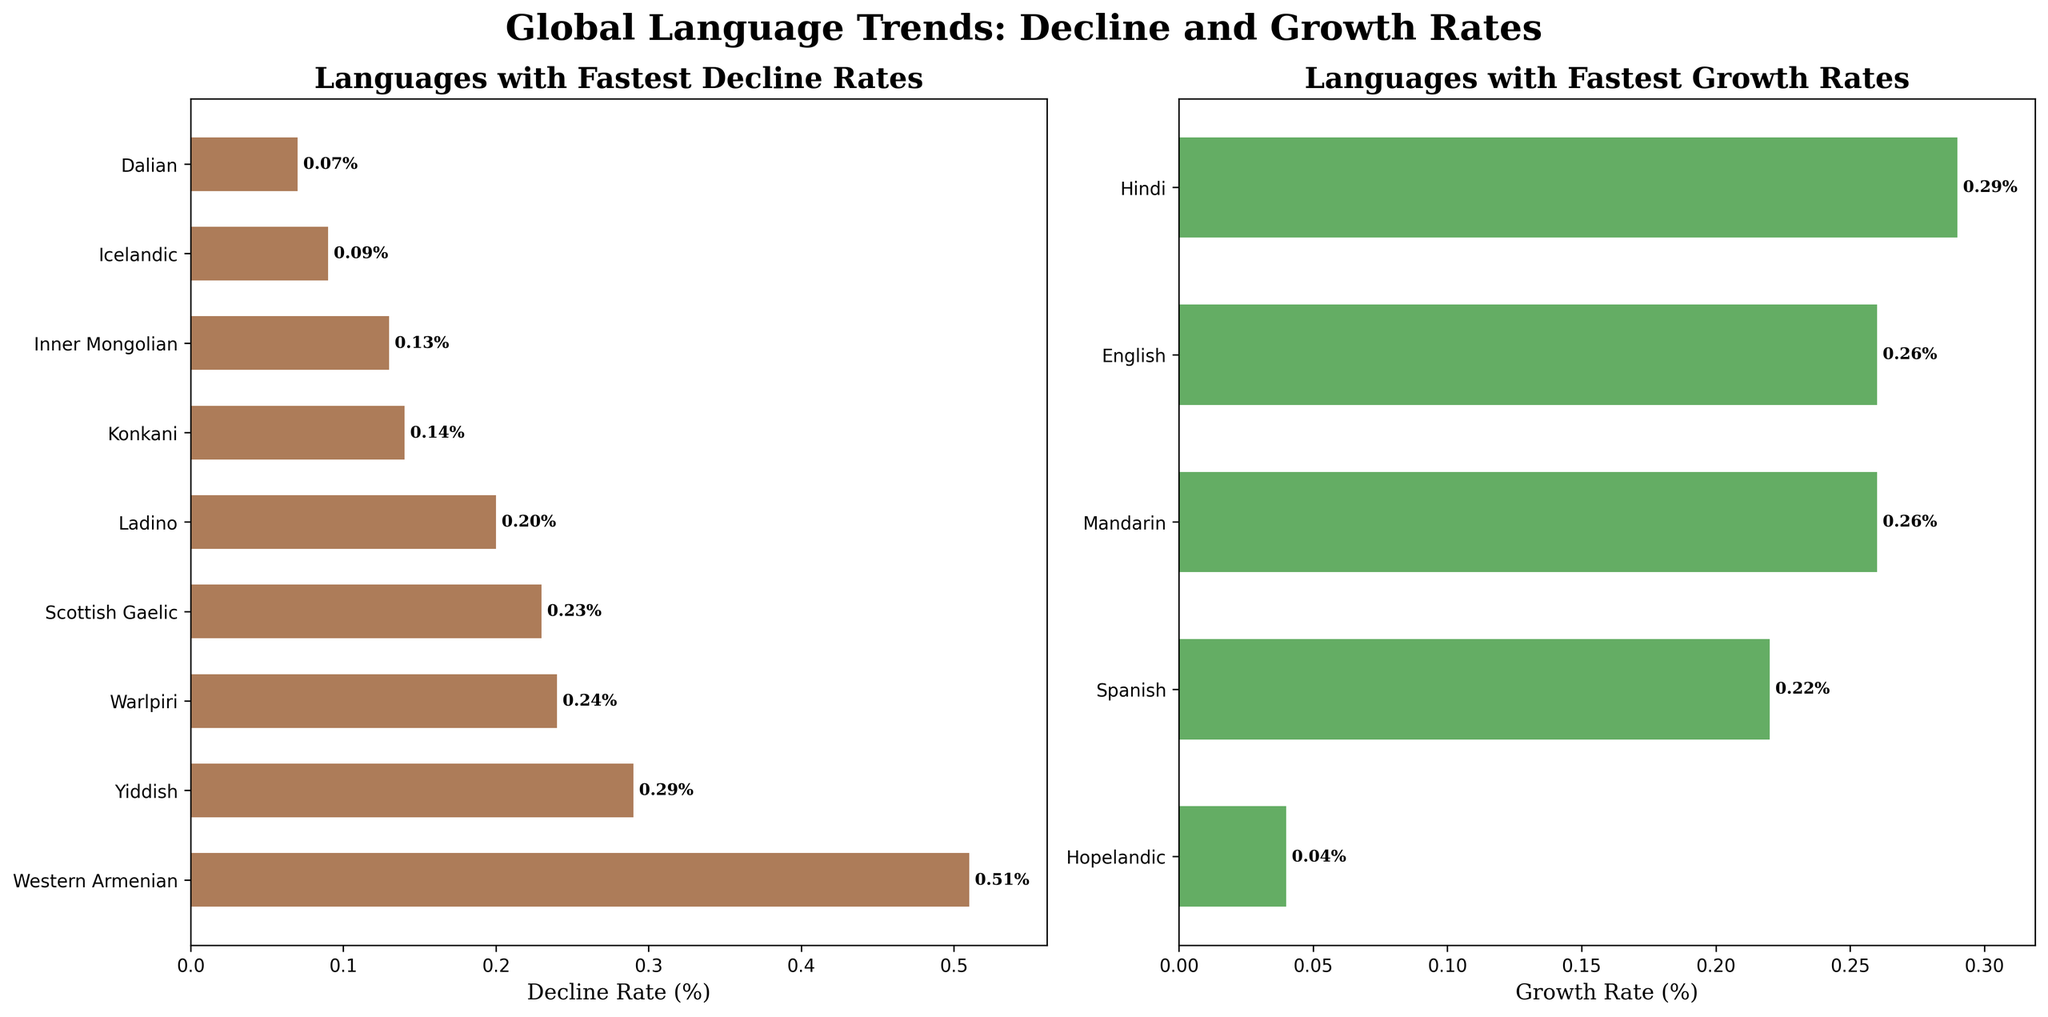What is the title of the figure? The title is displayed at the top of the figure in large, bold, and serif font, indicating the overall theme of the figure.
Answer: Global Language Trends: Decline and Growth Rates Which languages are shown to have the fastest decline rate? The left subplot titled "Languages with Fastest Decline Rates" shows languages with the fastest decline rates. From the top of the bar chart, we can see that Western Armenian has the highest decline rate.
Answer: Western Armenian How many languages are presented in the "Languages with Fastest Growth Rates" subplot? In the right subplot titled "Languages with Fastest Growth Rates," counting the bars will give the number of languages shown. There are five bars in this subplot.
Answer: 5 Between Mandarin and English, which language has a higher projected growth rate and what are the values? The right subplot lists Mandarin and English’s growth rates side-by-side. By comparing the two bars’ lengths, we see Mandarin has a growth rate of 0.26%, and English also at 0.26%.
Answer: They both have the same growth rate of 0.26% Which language has the lowest decline rate among the declining languages? In the left subplot titled "Languages with Fastest Decline Rates", the lowest bar represents the language with the smallest decline rate. The language at the bottom is Dalian.
Answer: Dalian How does the growth rate of Spanish compare to that of Hindi? Both growth rates can be found in the right subplot. Spanish’s bar shows a growth rate of 0.22%, whereas Hindi's bar shows a growth rate of 0.29%. Since Hindi’s bar is longer, Hindi has a higher growth rate.
Answer: Hindi has a higher growth rate If the growth rate of Hopelandic were doubled, would it surpass the growth rate of any languages shown in the growth rates plot? First, check Hopelandic’s current growth rate in the right subplot, which is 0.04%. Doubling 0.04% gives 0.08%, which is still lower than the current lowest growth rate (Spanish at 0.22%) shown in the growth rates plot. Therefore, it wouldn't surpass any languages.
Answer: No How many languages have a decline rate between 0.10% and 0.30%? Focus on the left subplot and note the bar lengths for each language. Western Armenian (0.51%) and Dalian (0.07%) are outside this range. The remaining are Scottish Gaelic, Yiddish, Ladino, Inner Mongolian, Icelandic, and Warlpiri which have decline rates within 0.10% and 0.30%.
Answer: 6 What is the average decline rate of Scottish Gaelic and Ladino? Locate Scottish Gaelic and Ladino on the left subplot. Scottish Gaelic has a decline rate of 0.23% and Ladino has 0.20%. Calculate the average by adding the two rates and dividing by 2: (0.23% + 0.20%)/2 = 0.215%.
Answer: 0.215% Between Yiddish and Hopelandic, which language category (declining or growing) does each belong to and how can you tell? Yiddish appears on the left subplot ("Languages with Fastest Decline Rates") showing it is in decline. Hopelandic appears on the right subplot ("Languages with Fastest Growth Rates") showing it is growing.
Answer: Yiddish is declining, Hopelandic is growing 